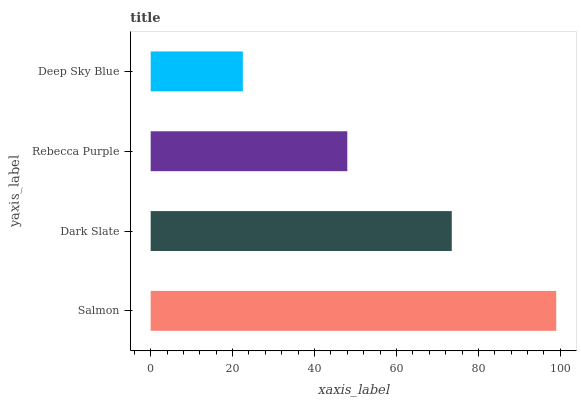Is Deep Sky Blue the minimum?
Answer yes or no. Yes. Is Salmon the maximum?
Answer yes or no. Yes. Is Dark Slate the minimum?
Answer yes or no. No. Is Dark Slate the maximum?
Answer yes or no. No. Is Salmon greater than Dark Slate?
Answer yes or no. Yes. Is Dark Slate less than Salmon?
Answer yes or no. Yes. Is Dark Slate greater than Salmon?
Answer yes or no. No. Is Salmon less than Dark Slate?
Answer yes or no. No. Is Dark Slate the high median?
Answer yes or no. Yes. Is Rebecca Purple the low median?
Answer yes or no. Yes. Is Rebecca Purple the high median?
Answer yes or no. No. Is Salmon the low median?
Answer yes or no. No. 